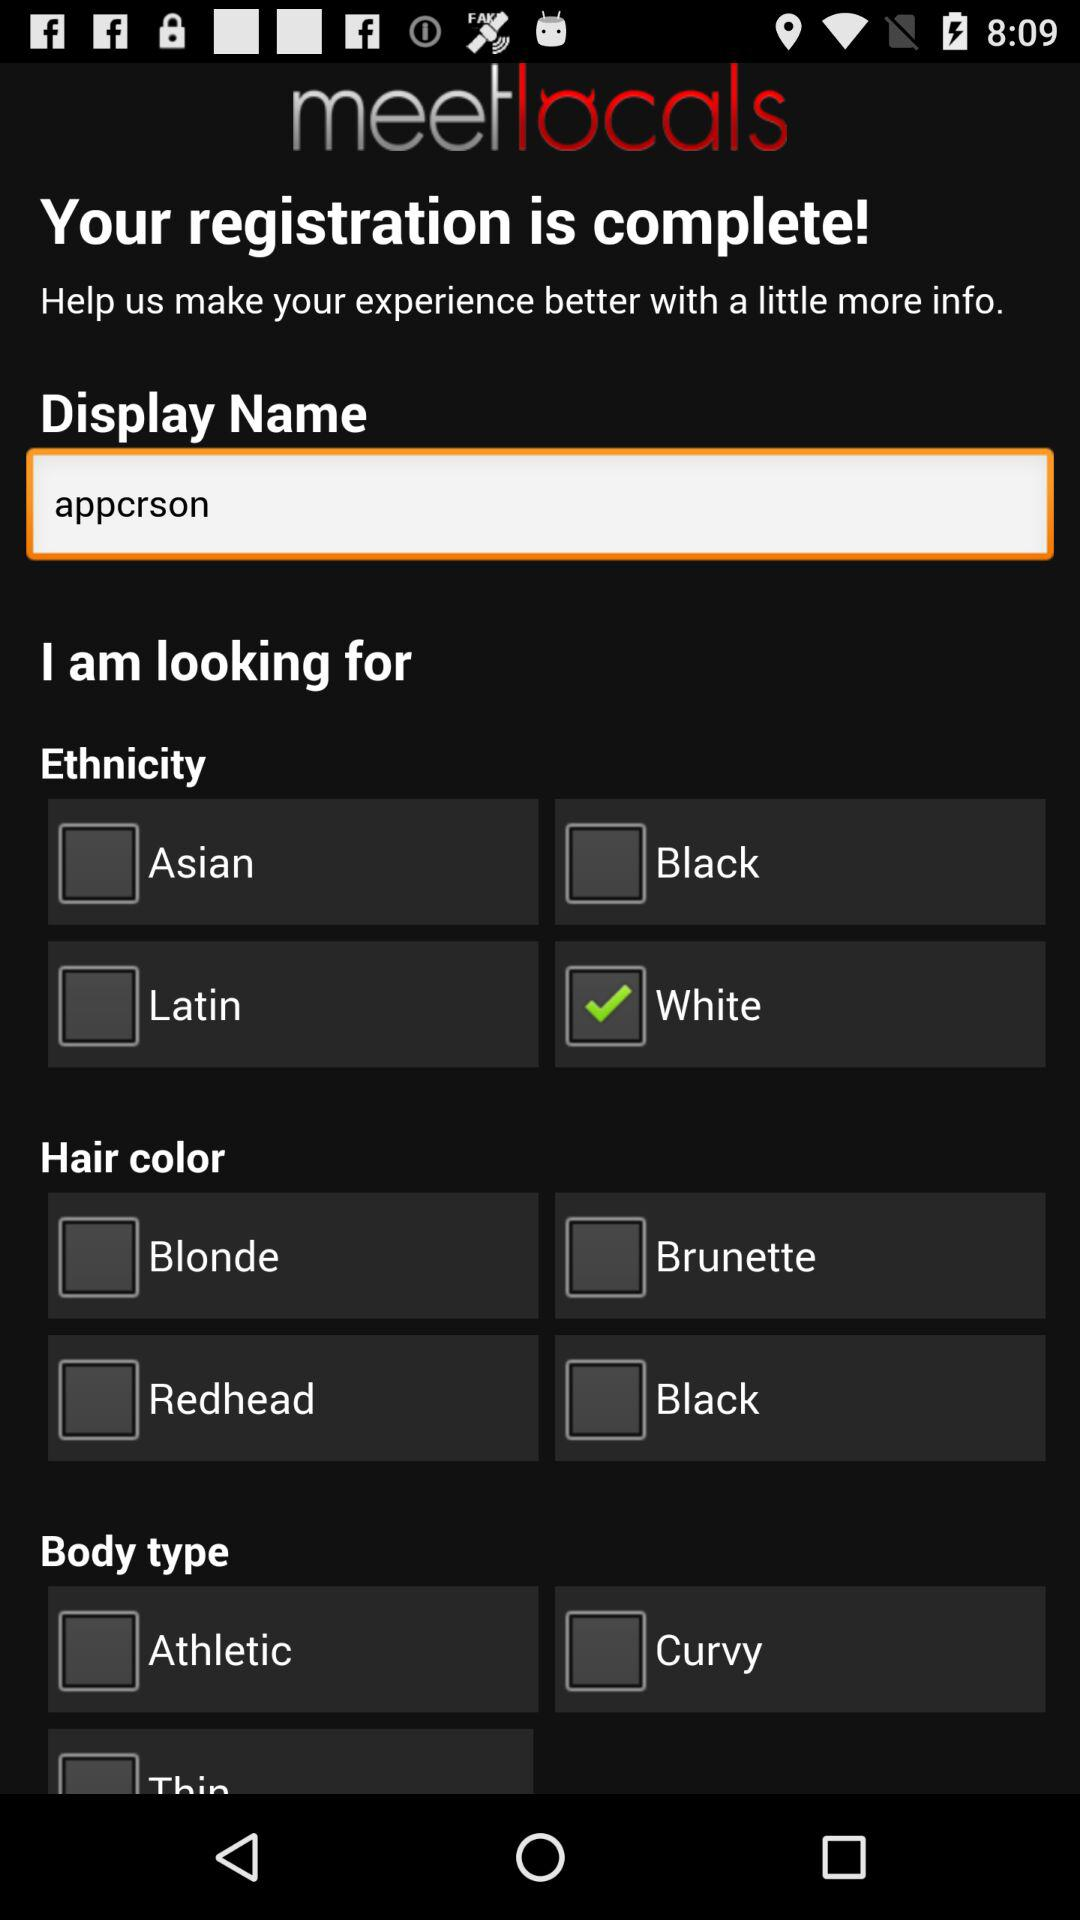What is the current status of "Black" in "Ethnicity"? The status is "off". 